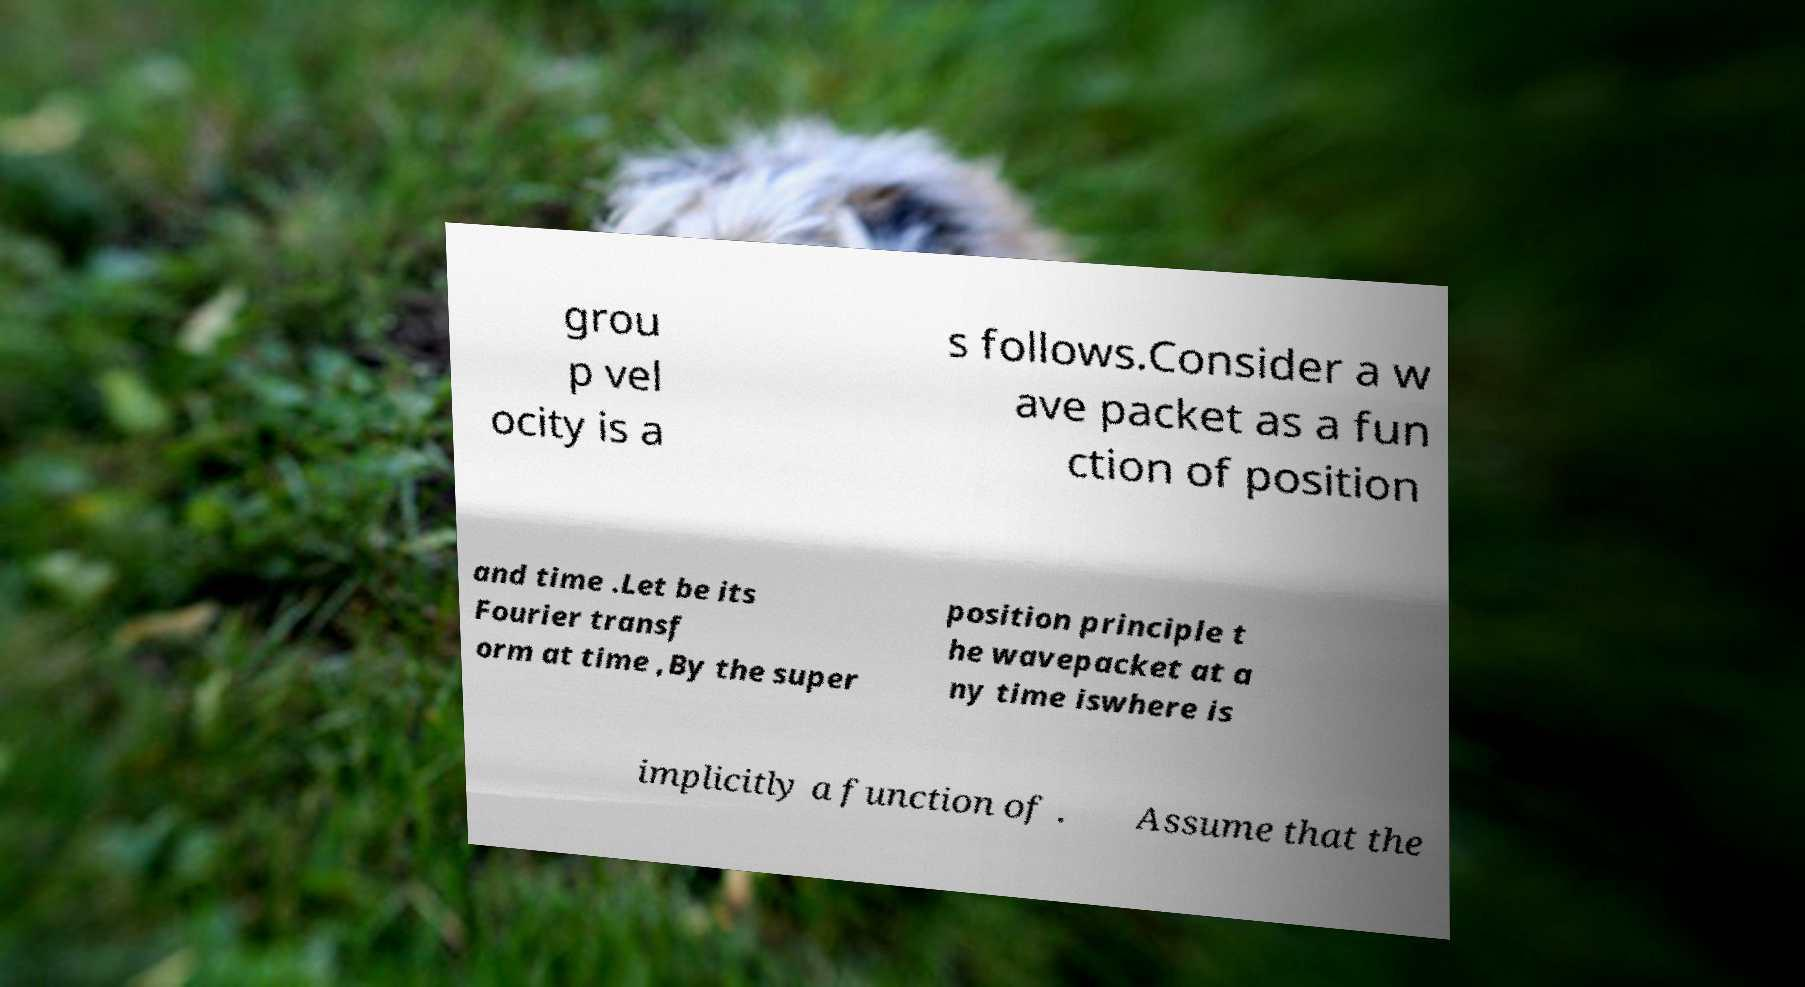Could you assist in decoding the text presented in this image and type it out clearly? grou p vel ocity is a s follows.Consider a w ave packet as a fun ction of position and time .Let be its Fourier transf orm at time ,By the super position principle t he wavepacket at a ny time iswhere is implicitly a function of . Assume that the 